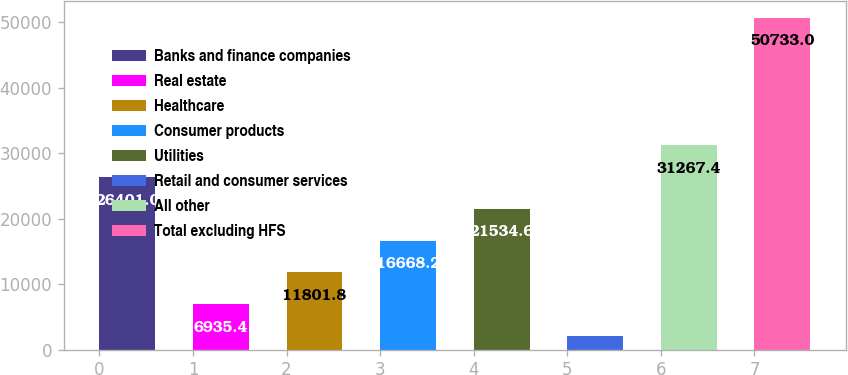Convert chart to OTSL. <chart><loc_0><loc_0><loc_500><loc_500><bar_chart><fcel>Banks and finance companies<fcel>Real estate<fcel>Healthcare<fcel>Consumer products<fcel>Utilities<fcel>Retail and consumer services<fcel>All other<fcel>Total excluding HFS<nl><fcel>26401<fcel>6935.4<fcel>11801.8<fcel>16668.2<fcel>21534.6<fcel>2069<fcel>31267.4<fcel>50733<nl></chart> 